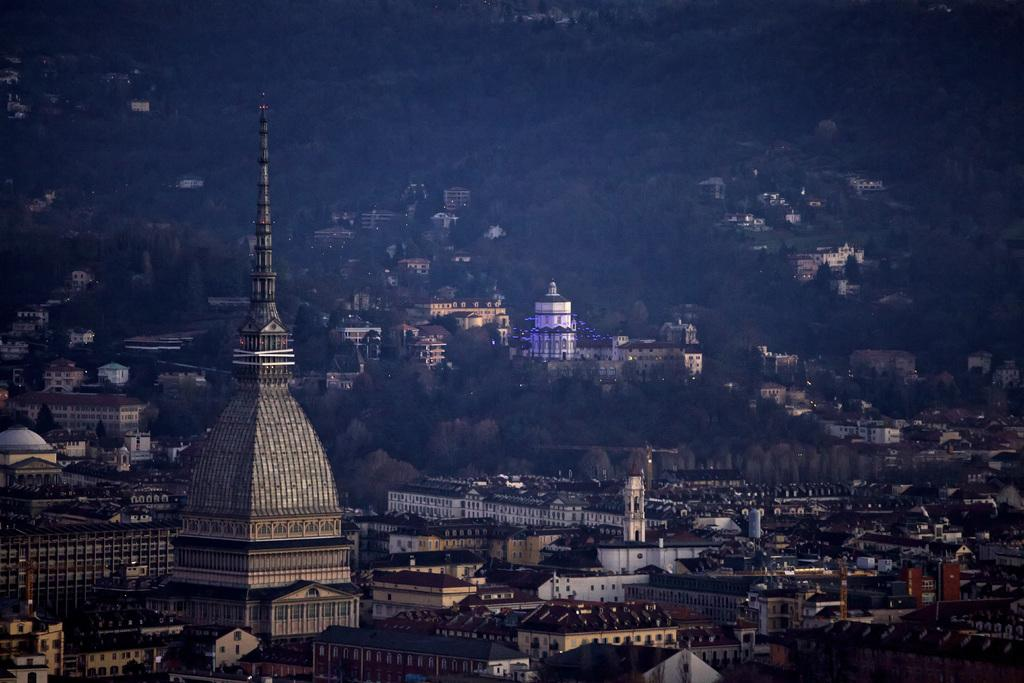What type of structures can be seen in the image? There is a group of buildings in the image. What type of vegetation is present in the image? There is a group of trees in the image. Can you tell me how many servants are visible in the image? There are no servants present in the image. What type of locket can be seen hanging from the tree in the image? There is no locket present in the image; it only features a group of trees. 